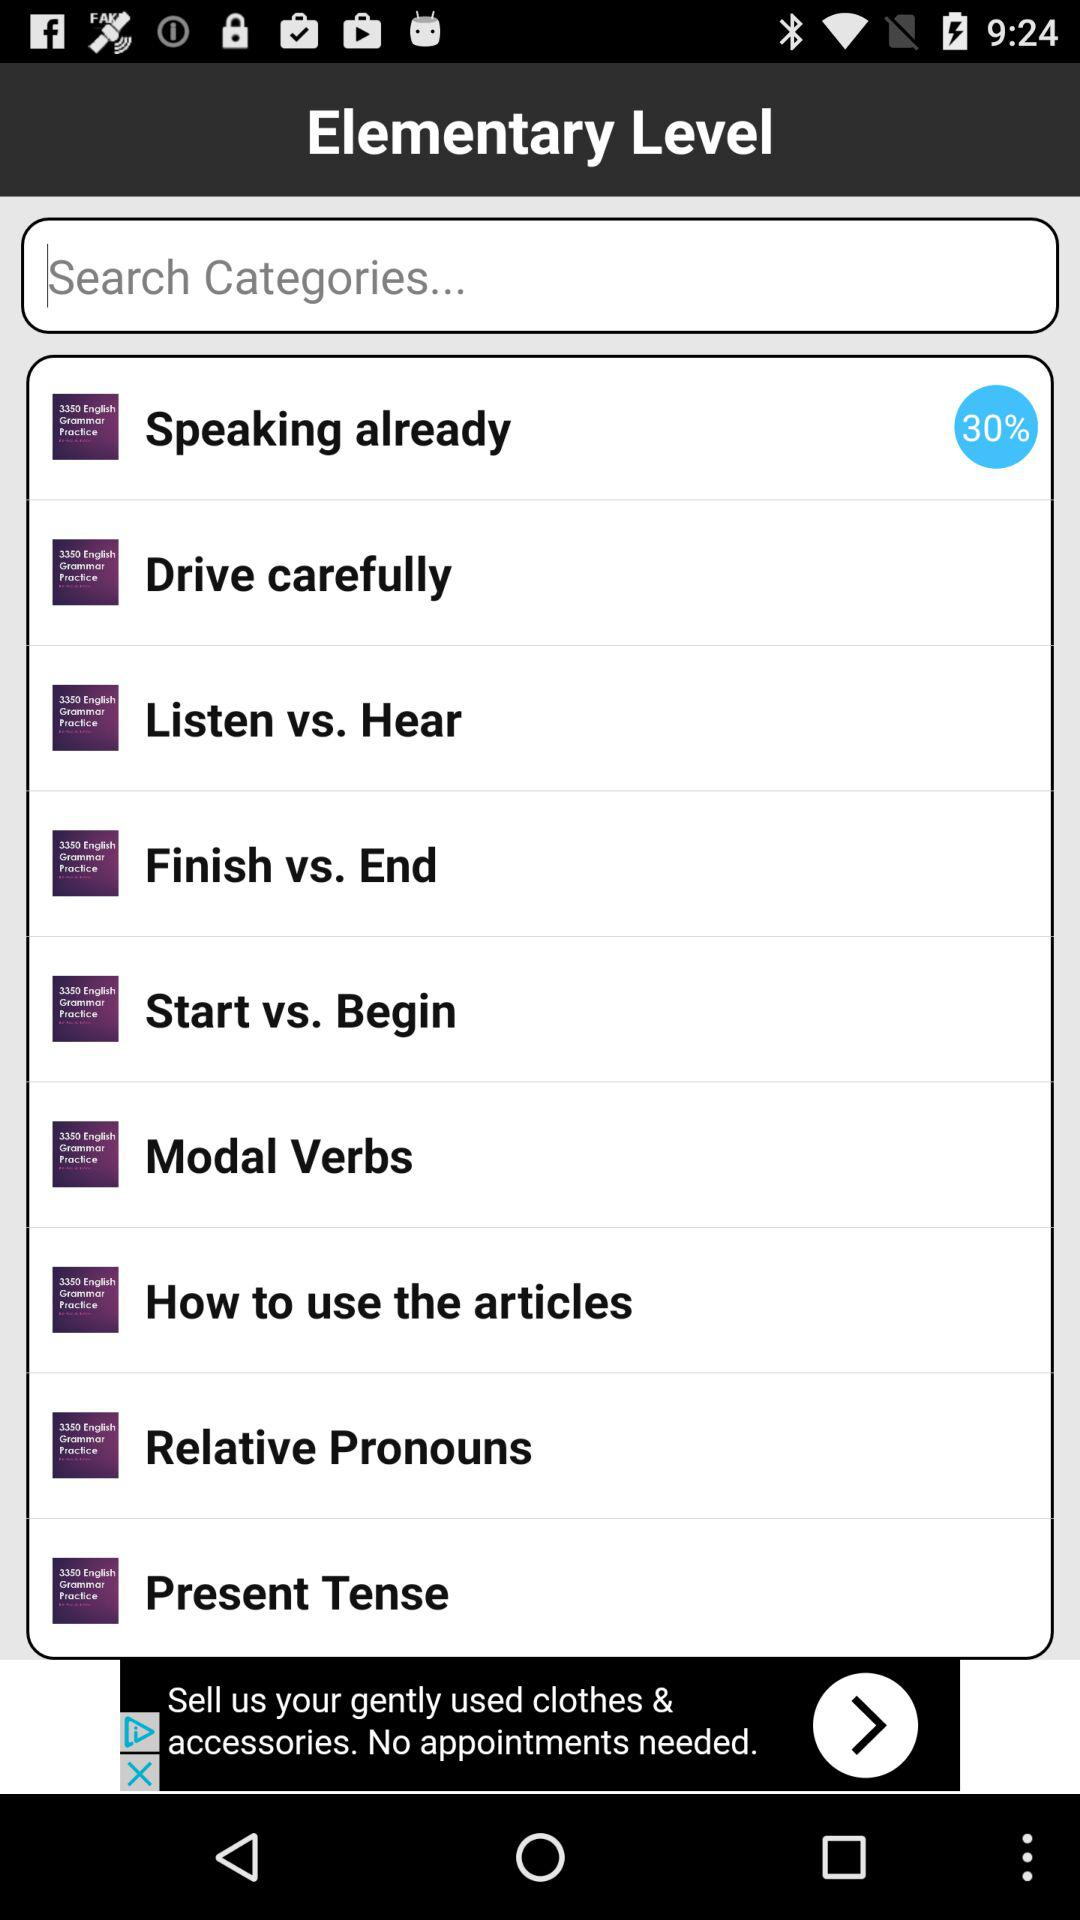What is the percentage of "Speaking already"? The percentage of "Speaking already" is 30. 